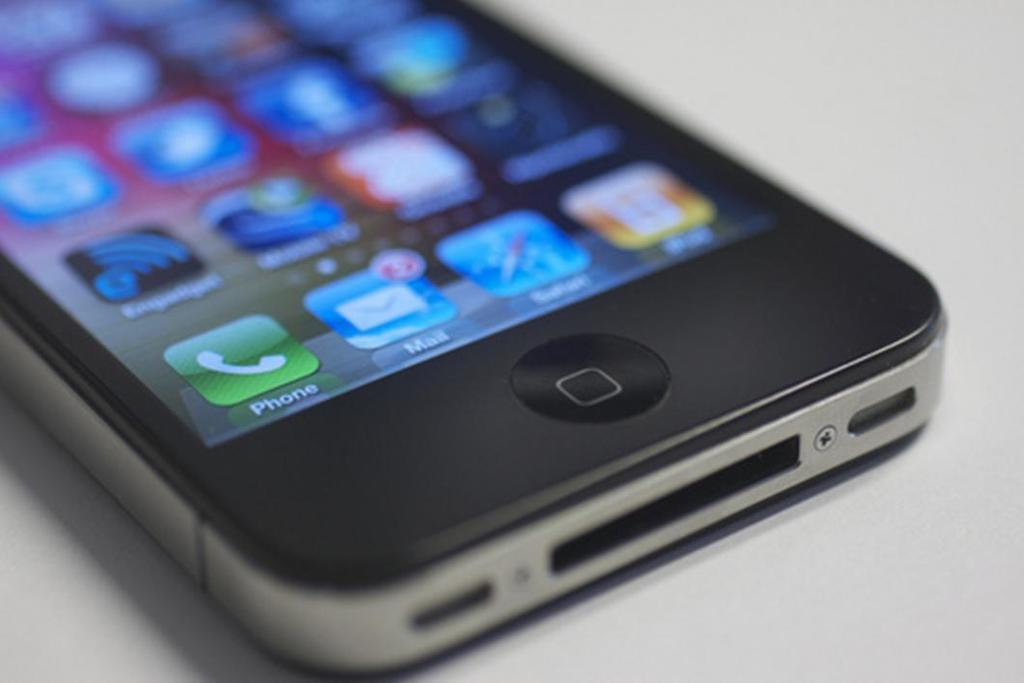What does the green icon say?
Provide a short and direct response. Phone. What is the text under the letter icon?
Your answer should be compact. Mail. 